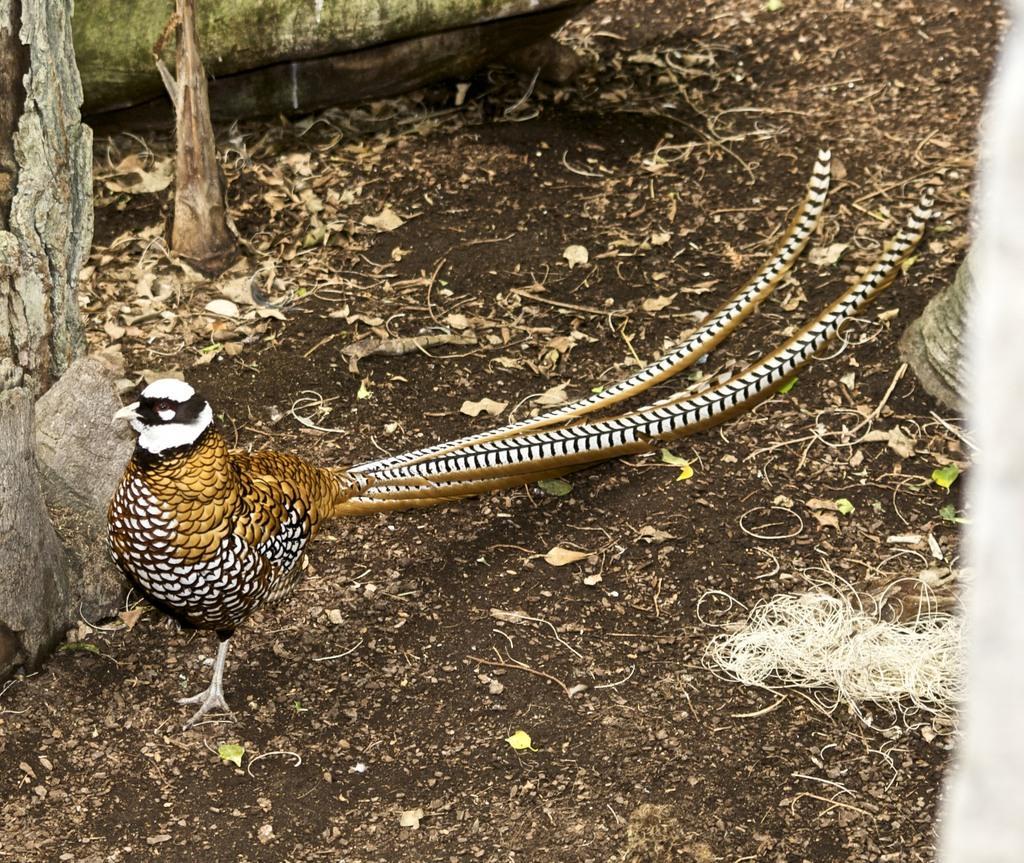Could you give a brief overview of what you see in this image? In this image we can see a bird on the land. Behind books are there. 